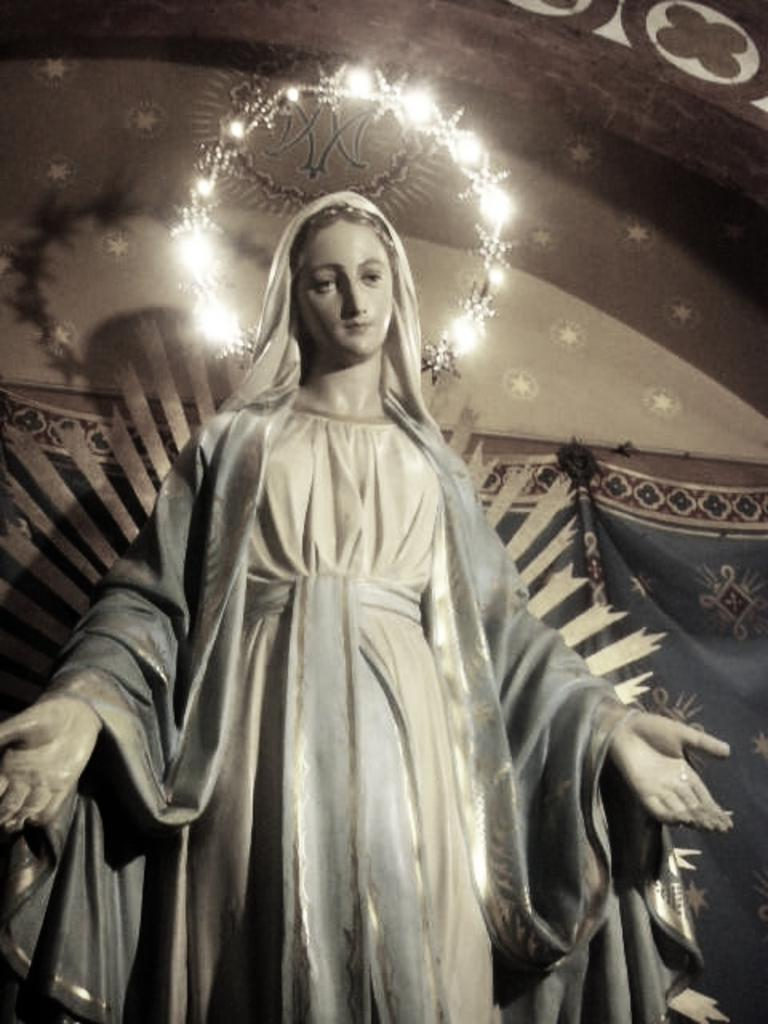What is the main subject in the center of the image? There is a statue in the center of the image. What can be seen in the background of the image? There are lights and a few other objects visible in the background of the image. What type of drink is being offered by the statue in the image? There is no drink present in the image; it features a statue and background lights and objects. 